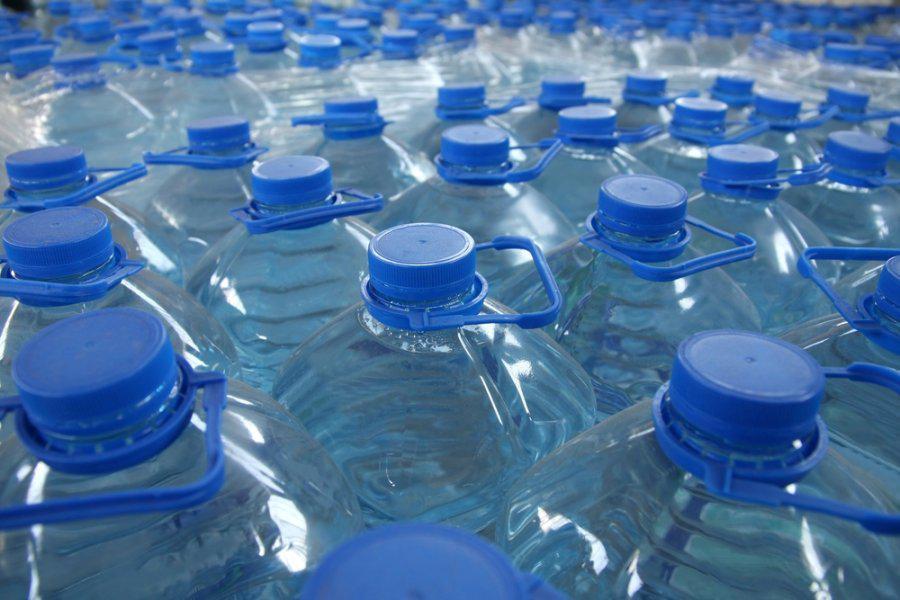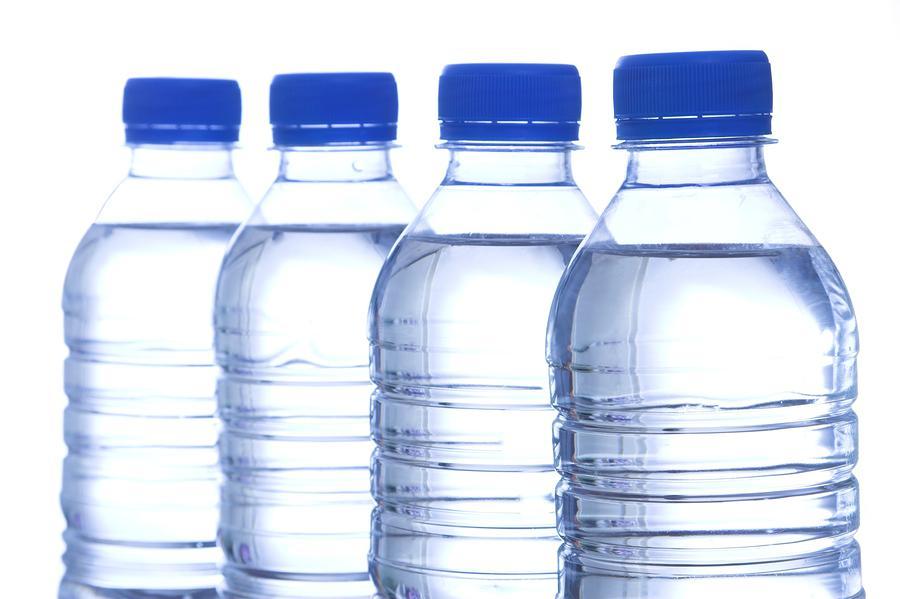The first image is the image on the left, the second image is the image on the right. Considering the images on both sides, is "There are exactly four bottles of water in one of the images." valid? Answer yes or no. Yes. 